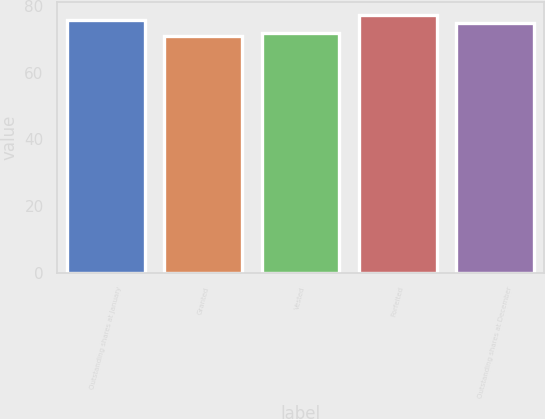<chart> <loc_0><loc_0><loc_500><loc_500><bar_chart><fcel>Outstanding shares at January<fcel>Granted<fcel>Vested<fcel>Forfeited<fcel>Outstanding shares at December<nl><fcel>75.88<fcel>70.89<fcel>71.83<fcel>77.38<fcel>74.8<nl></chart> 